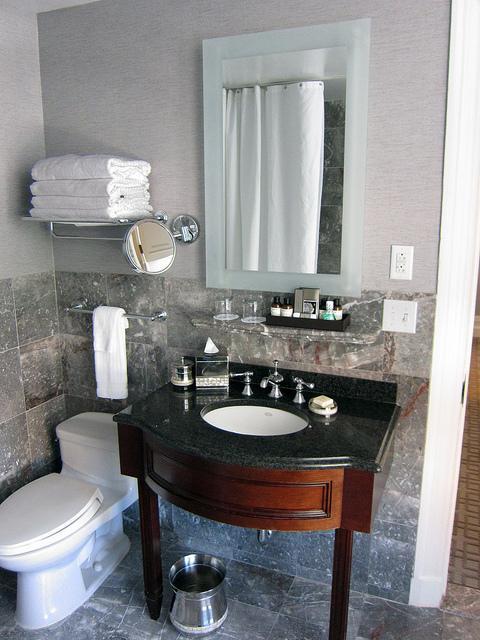How many towels are folded above the toilet?
Give a very brief answer. 4. How many keyboards are on the desk?
Give a very brief answer. 0. 